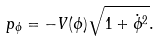Convert formula to latex. <formula><loc_0><loc_0><loc_500><loc_500>p _ { \phi } = - V ( \phi ) \sqrt { 1 + \dot { \phi } ^ { 2 } } .</formula> 